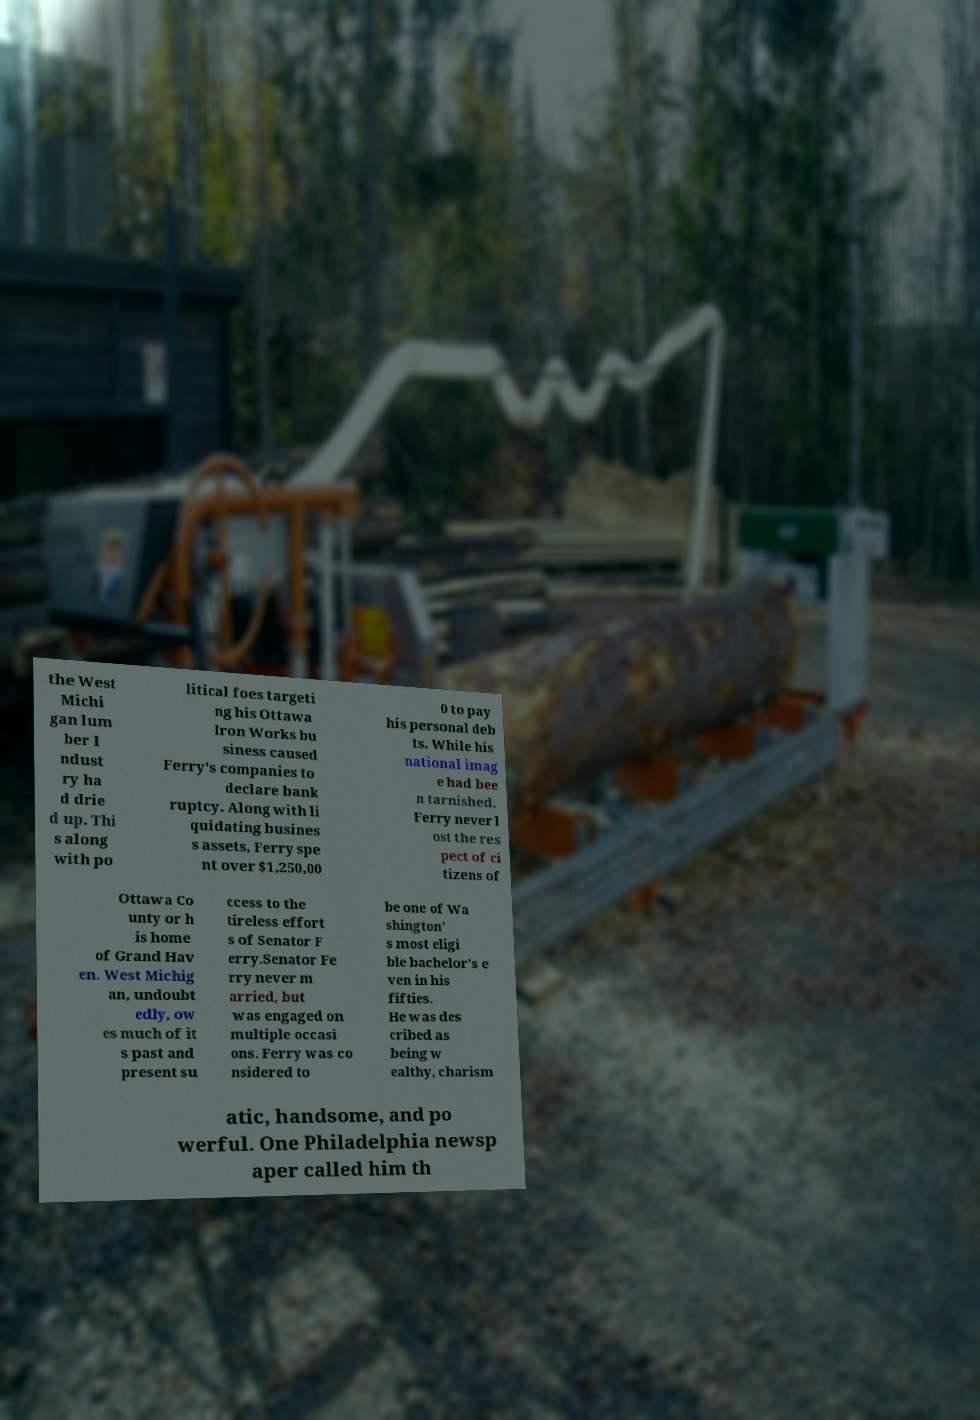Could you assist in decoding the text presented in this image and type it out clearly? the West Michi gan lum ber I ndust ry ha d drie d up. Thi s along with po litical foes targeti ng his Ottawa Iron Works bu siness caused Ferry's companies to declare bank ruptcy. Along with li quidating busines s assets, Ferry spe nt over $1,250,00 0 to pay his personal deb ts. While his national imag e had bee n tarnished, Ferry never l ost the res pect of ci tizens of Ottawa Co unty or h is home of Grand Hav en. West Michig an, undoubt edly, ow es much of it s past and present su ccess to the tireless effort s of Senator F erry.Senator Fe rry never m arried, but was engaged on multiple occasi ons. Ferry was co nsidered to be one of Wa shington' s most eligi ble bachelor's e ven in his fifties. He was des cribed as being w ealthy, charism atic, handsome, and po werful. One Philadelphia newsp aper called him th 